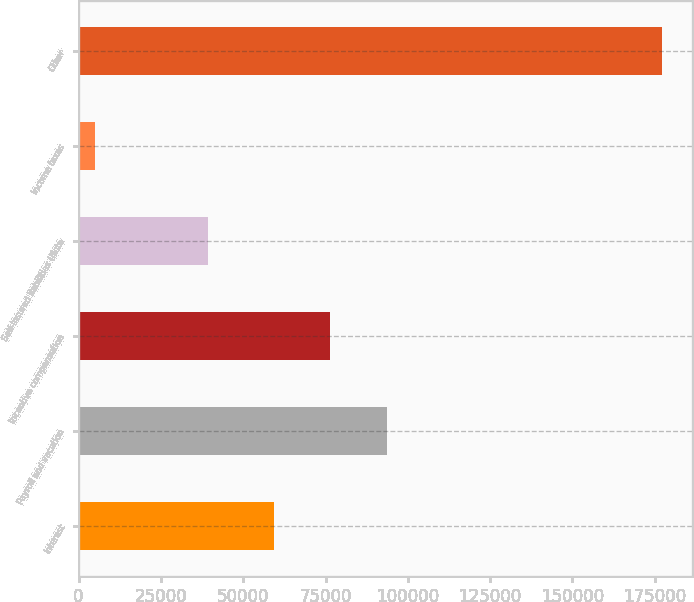Convert chart. <chart><loc_0><loc_0><loc_500><loc_500><bar_chart><fcel>Interest<fcel>Payroll and vacation<fcel>Incentive compensation<fcel>Self-insured liabilities (Note<fcel>Income taxes<fcel>Other<nl><fcel>59268<fcel>93739.4<fcel>76503.7<fcel>39358<fcel>4957<fcel>177314<nl></chart> 